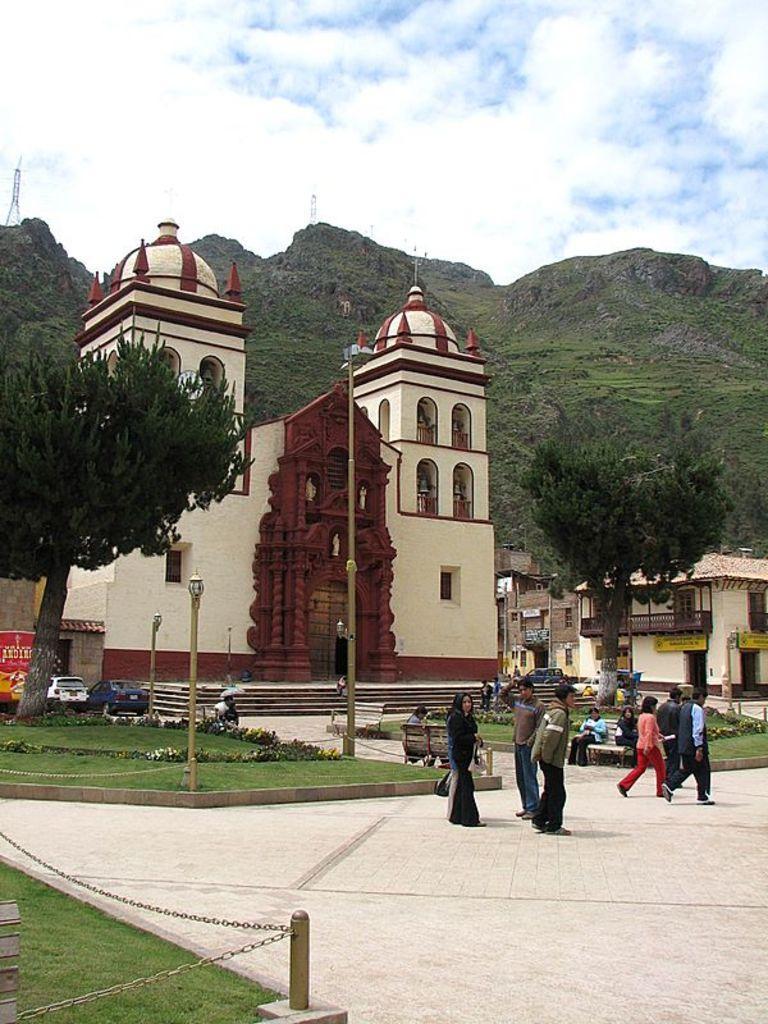Describe this image in one or two sentences. In the foreground I can see fence, grass, light poles, plants, group of people are walking on the road and few are sitting on the benches. In the background I can see a crowd, vehicles on the road, buildings, trees, mountains, towers and the sky. This image is taken may be during a day. 